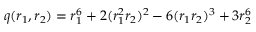Convert formula to latex. <formula><loc_0><loc_0><loc_500><loc_500>q ( r _ { 1 } , r _ { 2 } ) = r _ { 1 } ^ { 6 } + 2 ( r _ { 1 } ^ { 2 } r _ { 2 } ) ^ { 2 } - 6 ( r _ { 1 } r _ { 2 } ) ^ { 3 } + 3 r _ { 2 } ^ { 6 }</formula> 